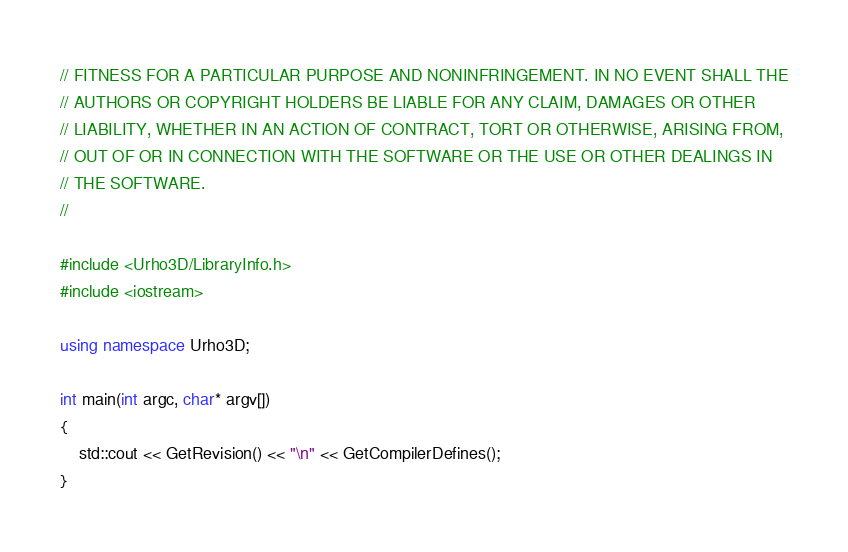<code> <loc_0><loc_0><loc_500><loc_500><_C++_>// FITNESS FOR A PARTICULAR PURPOSE AND NONINFRINGEMENT. IN NO EVENT SHALL THE
// AUTHORS OR COPYRIGHT HOLDERS BE LIABLE FOR ANY CLAIM, DAMAGES OR OTHER
// LIABILITY, WHETHER IN AN ACTION OF CONTRACT, TORT OR OTHERWISE, ARISING FROM,
// OUT OF OR IN CONNECTION WITH THE SOFTWARE OR THE USE OR OTHER DEALINGS IN
// THE SOFTWARE.
//

#include <Urho3D/LibraryInfo.h>
#include <iostream>

using namespace Urho3D;

int main(int argc, char* argv[])
{
    std::cout << GetRevision() << "\n" << GetCompilerDefines();
}
</code> 